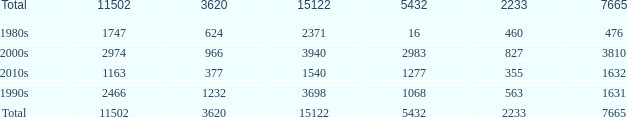What is the highest 3620 value with a 5432 of 5432 and a 15122 greater than 15122? None. 